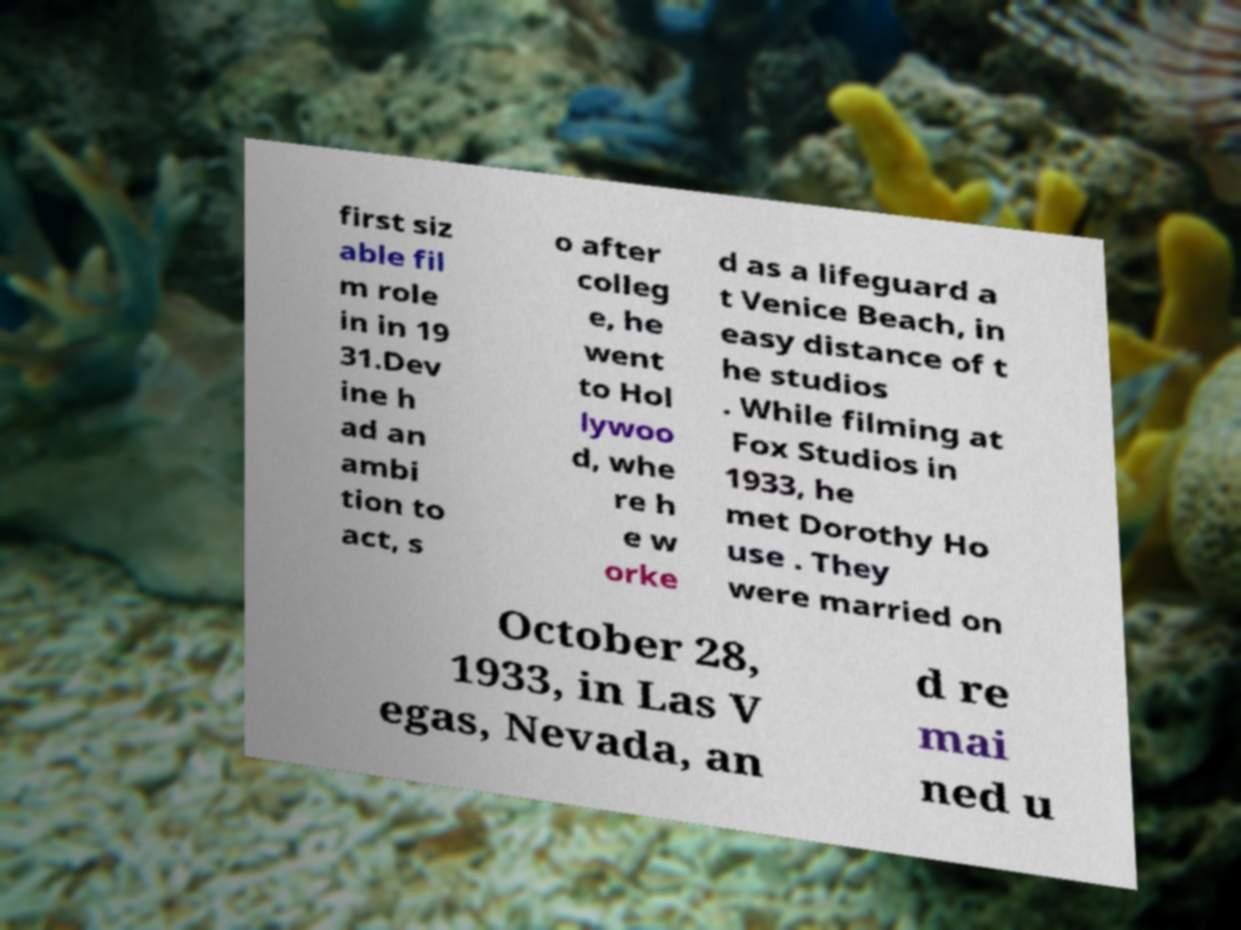Can you read and provide the text displayed in the image?This photo seems to have some interesting text. Can you extract and type it out for me? first siz able fil m role in in 19 31.Dev ine h ad an ambi tion to act, s o after colleg e, he went to Hol lywoo d, whe re h e w orke d as a lifeguard a t Venice Beach, in easy distance of t he studios . While filming at Fox Studios in 1933, he met Dorothy Ho use . They were married on October 28, 1933, in Las V egas, Nevada, an d re mai ned u 